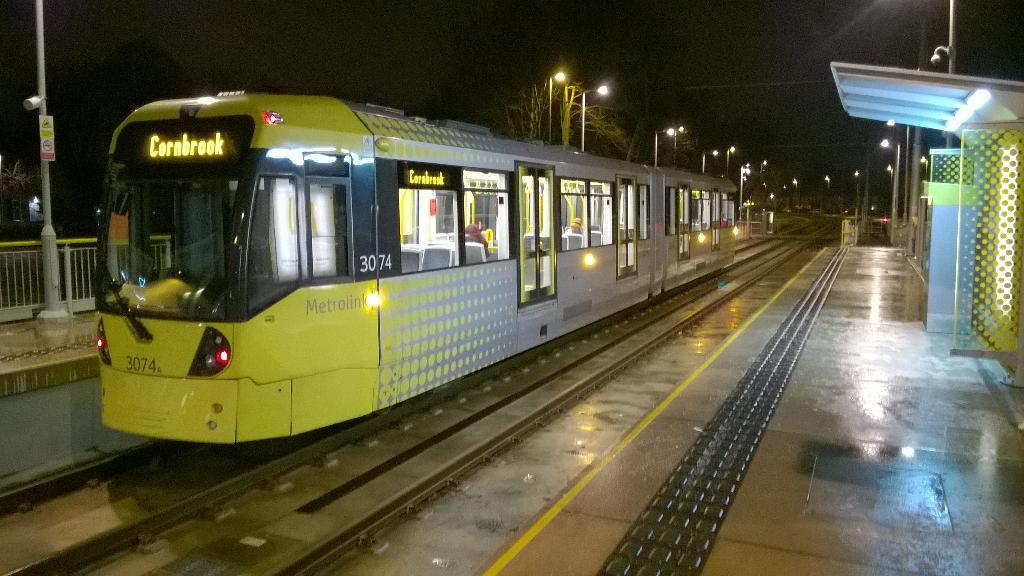<image>
Summarize the visual content of the image. Train station with a yellow and silver train with Cornbrook on the front. 